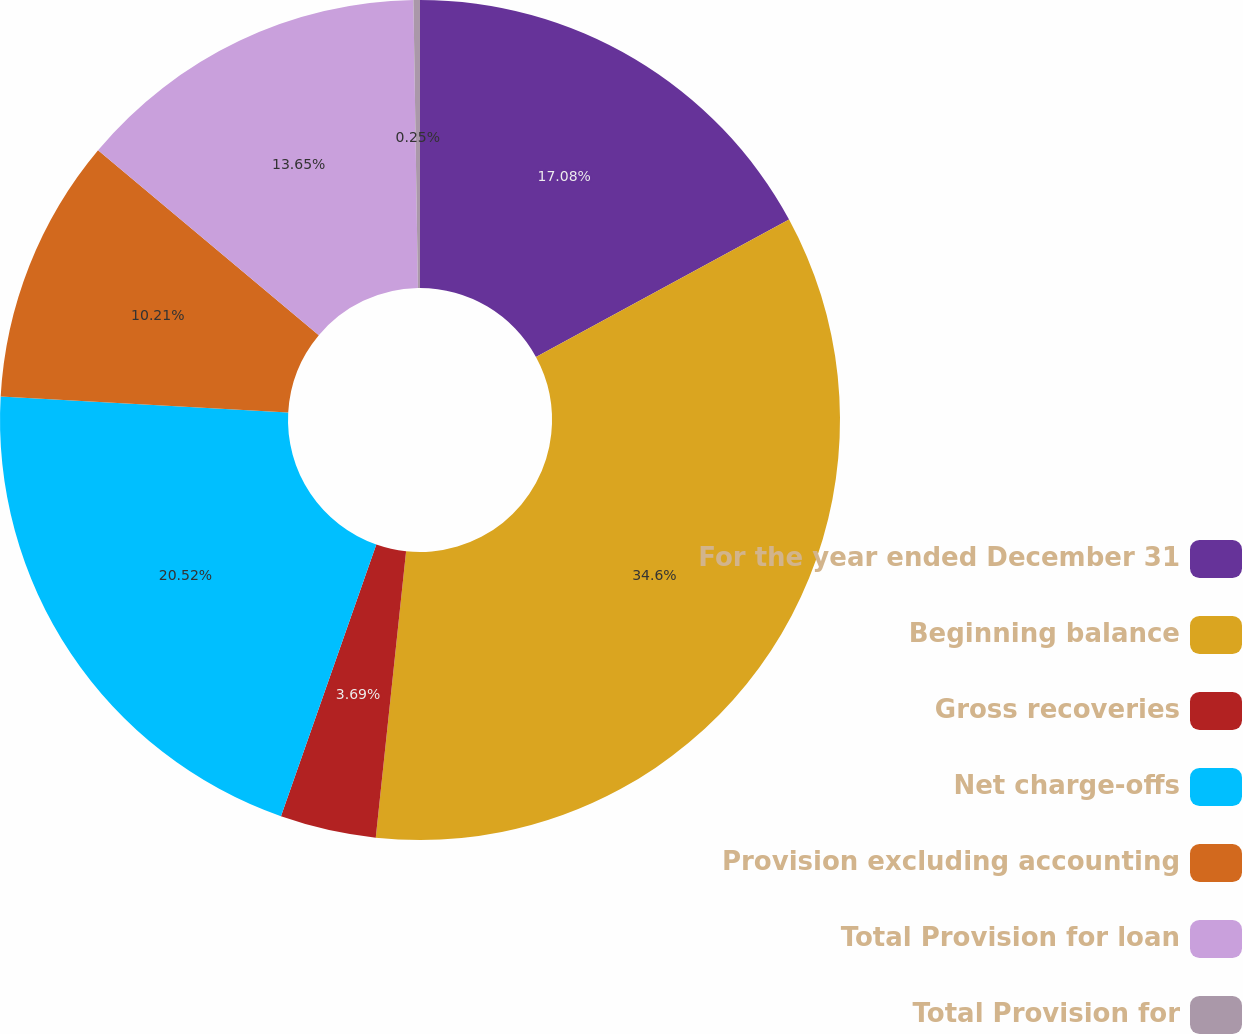<chart> <loc_0><loc_0><loc_500><loc_500><pie_chart><fcel>For the year ended December 31<fcel>Beginning balance<fcel>Gross recoveries<fcel>Net charge-offs<fcel>Provision excluding accounting<fcel>Total Provision for loan<fcel>Total Provision for<nl><fcel>17.08%<fcel>34.6%<fcel>3.69%<fcel>20.52%<fcel>10.21%<fcel>13.65%<fcel>0.25%<nl></chart> 